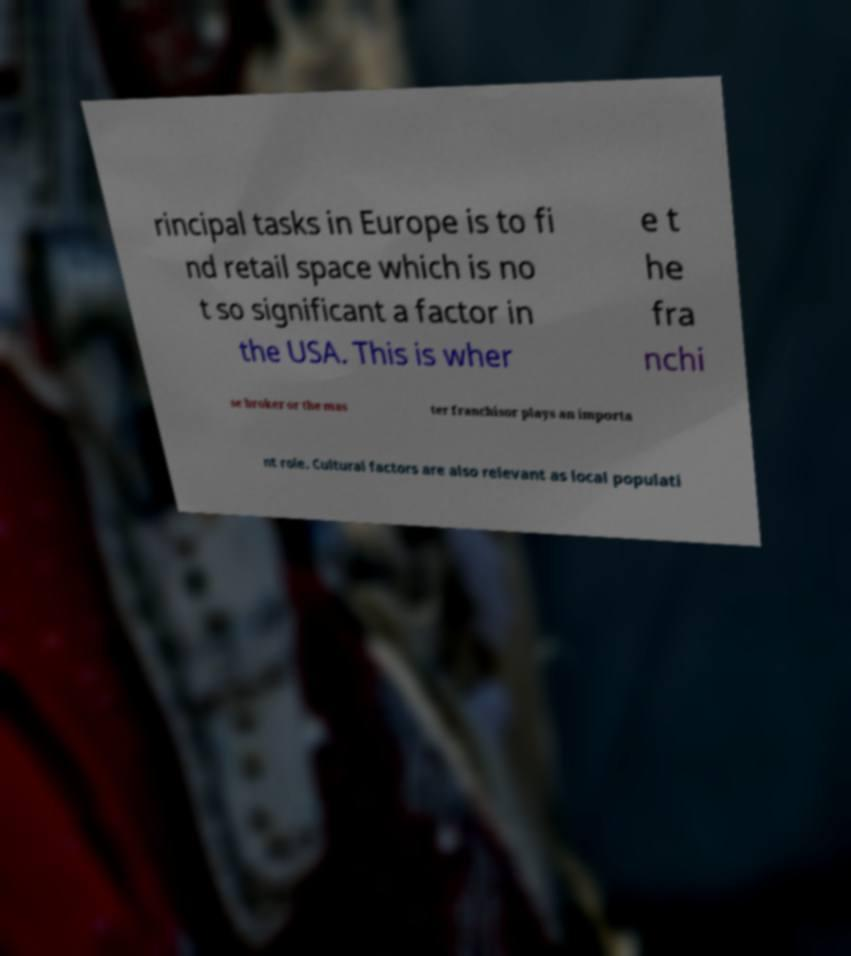Could you assist in decoding the text presented in this image and type it out clearly? rincipal tasks in Europe is to fi nd retail space which is no t so significant a factor in the USA. This is wher e t he fra nchi se broker or the mas ter franchisor plays an importa nt role. Cultural factors are also relevant as local populati 